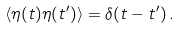<formula> <loc_0><loc_0><loc_500><loc_500>\left \langle \eta ( t ) \eta ( t ^ { \prime } ) \right \rangle = \delta ( t - t ^ { \prime } ) \, .</formula> 